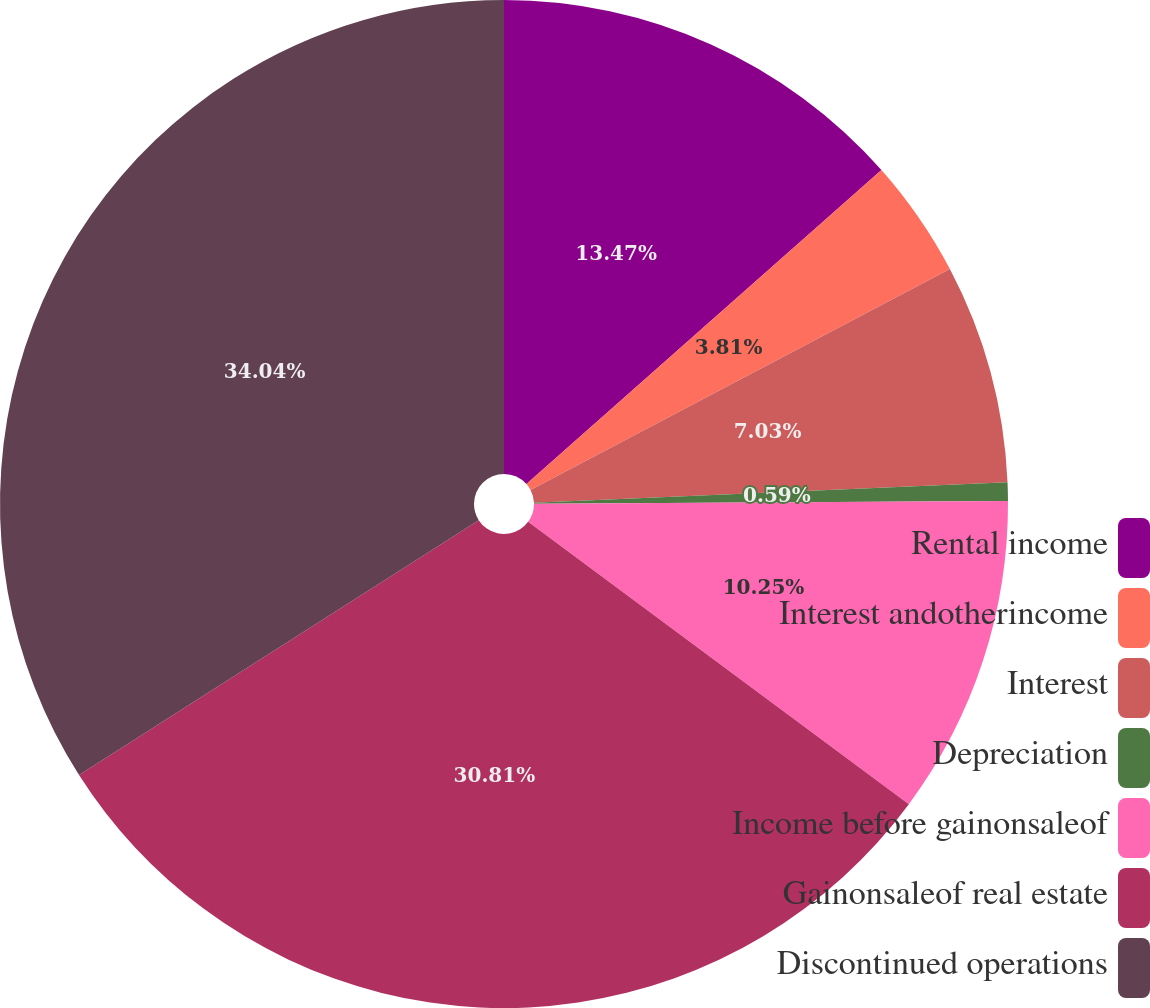Convert chart. <chart><loc_0><loc_0><loc_500><loc_500><pie_chart><fcel>Rental income<fcel>Interest andotherincome<fcel>Interest<fcel>Depreciation<fcel>Income before gainonsaleof<fcel>Gainonsaleof real estate<fcel>Discontinued operations<nl><fcel>13.47%<fcel>3.81%<fcel>7.03%<fcel>0.59%<fcel>10.25%<fcel>30.81%<fcel>34.03%<nl></chart> 